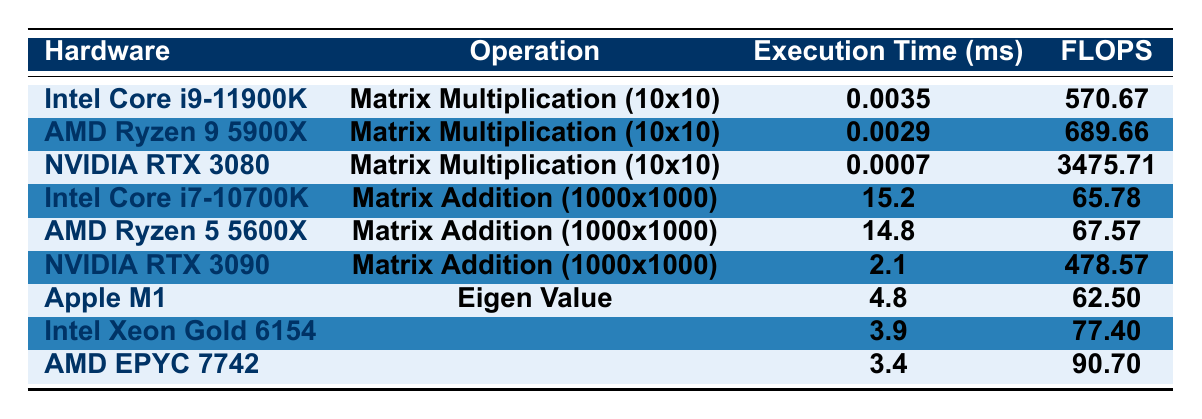What is the execution time of Matrix Multiplication on the NVIDIA RTX 3080? The execution time for the operation "Matrix Multiplication (10x10)" on the NVIDIA RTX 3080 is directly listed in the table under the corresponding hardware, which shows 0.0007 ms.
Answer: 0.0007 ms Which hardware has the highest FLOPS for Matrix Addition? The highest FLOPS value for "Matrix Addition (1000x1000)" is found by comparing the FLOPS values listed for that operation. The NVIDIA RTX 3090 has a FLOPS value of 478.57, which is the highest among the three listed.
Answer: NVIDIA RTX 3090 Is the execution time for Eigen Value Decomposition on AMD EPYC 7742 less than 4 ms? The execution time for "Eigen Value Decomposition (300x300)" on AMD EPYC 7742 is 3.4 ms, which is indeed less than 4 ms, confirming that the statement is true.
Answer: Yes What is the execution time difference between AMD Ryzen 9 5900X and Intel Core i9-11900K for Matrix Multiplication? The execution time for AMD Ryzen 9 5900X is 0.0029 ms and for Intel Core i9-11900K is 0.0035 ms. The difference is calculated as 0.0035 - 0.0029 = 0.0006 ms.
Answer: 0.0006 ms Which operation has a higher throughput based on FLOPS, Matrix Multiplication on NVIDIA RTX 3080 or Matrix Addition on Intel Core i7-10700K? The FLOPS for "Matrix Multiplication (10x10)" on NVIDIA RTX 3080 is 3475.71, while the FLOPS for "Matrix Addition (1000x1000)" on Intel Core i7-10700K is 65.78. Therefore, 3475.71 is greater than 65.78, showing the multiplication has a higher throughput.
Answer: Matrix Multiplication on NVIDIA RTX 3080 What is the average execution time for Matrix Addition operations? The execution times for Matrix Addition listed in the table are 15.2 ms (Intel Core i7-10700K), 14.8 ms (AMD Ryzen 5 5600X), and 2.1 ms (NVIDIA RTX 3090). The average is calculated as (15.2 + 14.8 + 2.1) / 3 = 10.4 ms.
Answer: 10.4 ms Is the performance of AMD EPYC 7742 for Eigen Value Decomposition better than that of Apple M1 based on FLOPS? The FLOPS for AMD EPYC 7742 is 90.70, while for Apple M1 it is 62.50. Since 90.70 is greater than 62.50, we confirm that the performance of AMD EPYC 7742 is indeed better in this case.
Answer: Yes How does the execution time for Matrix Addition on NVIDIA RTX 3090 compare to the average of the other two Matrix Addition executions? The execution time for NVIDIA RTX 3090 is 2.1 ms. The average of the other two (Intel Core i7-10700K at 15.2 ms and AMD Ryzen 5 5600X at 14.8 ms) is (15.2 + 14.8) / 2 = 15.0 ms. Since 2.1 ms is less than 15.0 ms, NVIDIA RTX 3090 is faster on average.
Answer: Faster What is the maximum execution time for Eigen Value Decomposition across all listed hardware? The execution times for Eigen Value Decomposition are 4.8 ms (Apple M1), 3.9 ms (Intel Xeon Gold 6154), and 3.4 ms (AMD EPYC 7742). The maximum value is 4.8 ms from Apple M1.
Answer: 4.8 ms 